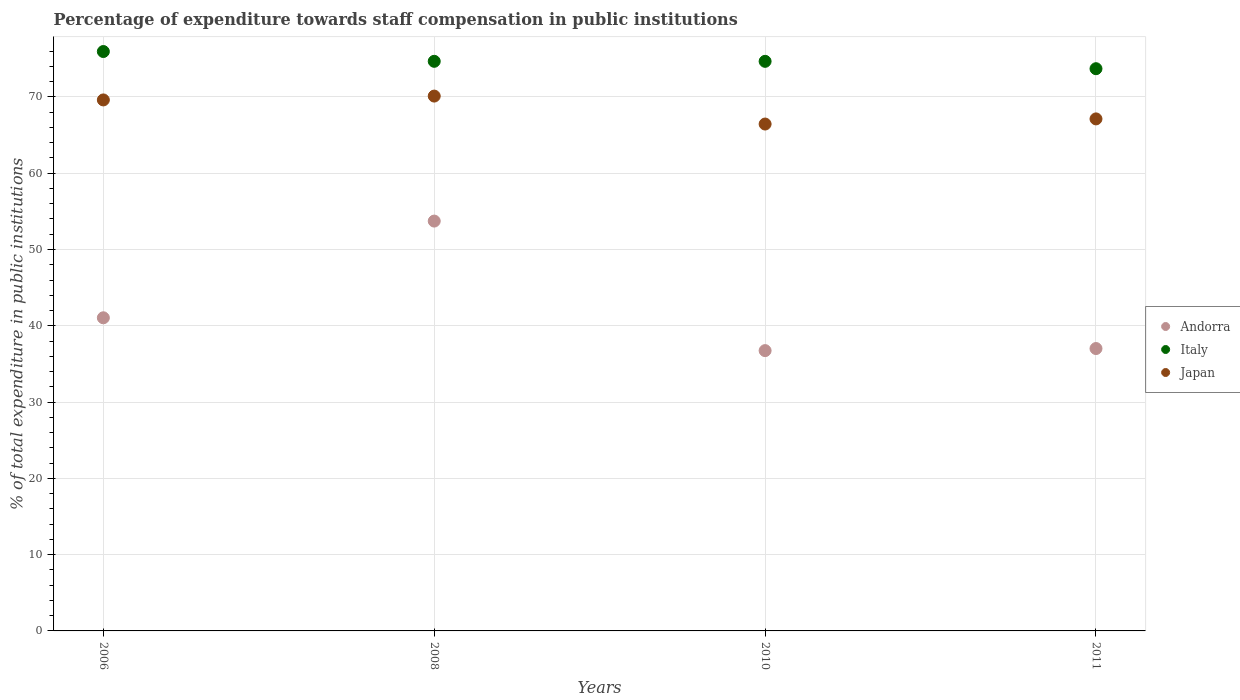What is the percentage of expenditure towards staff compensation in Japan in 2008?
Give a very brief answer. 70.11. Across all years, what is the maximum percentage of expenditure towards staff compensation in Japan?
Provide a succinct answer. 70.11. Across all years, what is the minimum percentage of expenditure towards staff compensation in Italy?
Offer a very short reply. 73.7. In which year was the percentage of expenditure towards staff compensation in Italy maximum?
Keep it short and to the point. 2006. In which year was the percentage of expenditure towards staff compensation in Japan minimum?
Your answer should be compact. 2010. What is the total percentage of expenditure towards staff compensation in Japan in the graph?
Your answer should be very brief. 273.28. What is the difference between the percentage of expenditure towards staff compensation in Italy in 2008 and that in 2011?
Your answer should be very brief. 0.97. What is the difference between the percentage of expenditure towards staff compensation in Italy in 2006 and the percentage of expenditure towards staff compensation in Japan in 2011?
Make the answer very short. 8.83. What is the average percentage of expenditure towards staff compensation in Japan per year?
Offer a terse response. 68.32. In the year 2010, what is the difference between the percentage of expenditure towards staff compensation in Japan and percentage of expenditure towards staff compensation in Italy?
Keep it short and to the point. -8.22. What is the ratio of the percentage of expenditure towards staff compensation in Italy in 2008 to that in 2010?
Your answer should be very brief. 1. Is the percentage of expenditure towards staff compensation in Andorra in 2008 less than that in 2011?
Provide a succinct answer. No. What is the difference between the highest and the second highest percentage of expenditure towards staff compensation in Japan?
Offer a very short reply. 0.51. What is the difference between the highest and the lowest percentage of expenditure towards staff compensation in Japan?
Your answer should be compact. 3.67. In how many years, is the percentage of expenditure towards staff compensation in Japan greater than the average percentage of expenditure towards staff compensation in Japan taken over all years?
Give a very brief answer. 2. Does the percentage of expenditure towards staff compensation in Italy monotonically increase over the years?
Keep it short and to the point. No. Is the percentage of expenditure towards staff compensation in Japan strictly greater than the percentage of expenditure towards staff compensation in Italy over the years?
Provide a succinct answer. No. Is the percentage of expenditure towards staff compensation in Japan strictly less than the percentage of expenditure towards staff compensation in Italy over the years?
Keep it short and to the point. Yes. How many years are there in the graph?
Keep it short and to the point. 4. What is the difference between two consecutive major ticks on the Y-axis?
Offer a terse response. 10. Does the graph contain any zero values?
Make the answer very short. No. Does the graph contain grids?
Your response must be concise. Yes. What is the title of the graph?
Offer a terse response. Percentage of expenditure towards staff compensation in public institutions. Does "Serbia" appear as one of the legend labels in the graph?
Your answer should be compact. No. What is the label or title of the X-axis?
Your answer should be compact. Years. What is the label or title of the Y-axis?
Provide a succinct answer. % of total expenditure in public institutions. What is the % of total expenditure in public institutions of Andorra in 2006?
Offer a terse response. 41.05. What is the % of total expenditure in public institutions of Italy in 2006?
Ensure brevity in your answer.  75.95. What is the % of total expenditure in public institutions of Japan in 2006?
Offer a very short reply. 69.61. What is the % of total expenditure in public institutions of Andorra in 2008?
Provide a short and direct response. 53.72. What is the % of total expenditure in public institutions of Italy in 2008?
Make the answer very short. 74.67. What is the % of total expenditure in public institutions of Japan in 2008?
Offer a terse response. 70.11. What is the % of total expenditure in public institutions of Andorra in 2010?
Your answer should be very brief. 36.74. What is the % of total expenditure in public institutions of Italy in 2010?
Give a very brief answer. 74.66. What is the % of total expenditure in public institutions of Japan in 2010?
Your answer should be very brief. 66.44. What is the % of total expenditure in public institutions in Andorra in 2011?
Provide a succinct answer. 37.02. What is the % of total expenditure in public institutions of Italy in 2011?
Offer a very short reply. 73.7. What is the % of total expenditure in public institutions in Japan in 2011?
Make the answer very short. 67.12. Across all years, what is the maximum % of total expenditure in public institutions in Andorra?
Your answer should be very brief. 53.72. Across all years, what is the maximum % of total expenditure in public institutions in Italy?
Your response must be concise. 75.95. Across all years, what is the maximum % of total expenditure in public institutions of Japan?
Your answer should be compact. 70.11. Across all years, what is the minimum % of total expenditure in public institutions of Andorra?
Keep it short and to the point. 36.74. Across all years, what is the minimum % of total expenditure in public institutions of Italy?
Make the answer very short. 73.7. Across all years, what is the minimum % of total expenditure in public institutions in Japan?
Give a very brief answer. 66.44. What is the total % of total expenditure in public institutions in Andorra in the graph?
Provide a short and direct response. 168.53. What is the total % of total expenditure in public institutions of Italy in the graph?
Ensure brevity in your answer.  298.98. What is the total % of total expenditure in public institutions of Japan in the graph?
Give a very brief answer. 273.28. What is the difference between the % of total expenditure in public institutions of Andorra in 2006 and that in 2008?
Provide a succinct answer. -12.68. What is the difference between the % of total expenditure in public institutions in Italy in 2006 and that in 2008?
Give a very brief answer. 1.28. What is the difference between the % of total expenditure in public institutions of Japan in 2006 and that in 2008?
Provide a succinct answer. -0.51. What is the difference between the % of total expenditure in public institutions in Andorra in 2006 and that in 2010?
Make the answer very short. 4.3. What is the difference between the % of total expenditure in public institutions in Italy in 2006 and that in 2010?
Offer a terse response. 1.29. What is the difference between the % of total expenditure in public institutions of Japan in 2006 and that in 2010?
Give a very brief answer. 3.16. What is the difference between the % of total expenditure in public institutions of Andorra in 2006 and that in 2011?
Offer a very short reply. 4.03. What is the difference between the % of total expenditure in public institutions of Italy in 2006 and that in 2011?
Your response must be concise. 2.25. What is the difference between the % of total expenditure in public institutions of Japan in 2006 and that in 2011?
Your answer should be very brief. 2.49. What is the difference between the % of total expenditure in public institutions in Andorra in 2008 and that in 2010?
Your answer should be very brief. 16.98. What is the difference between the % of total expenditure in public institutions in Italy in 2008 and that in 2010?
Give a very brief answer. 0. What is the difference between the % of total expenditure in public institutions of Japan in 2008 and that in 2010?
Your answer should be compact. 3.67. What is the difference between the % of total expenditure in public institutions in Andorra in 2008 and that in 2011?
Provide a succinct answer. 16.71. What is the difference between the % of total expenditure in public institutions in Italy in 2008 and that in 2011?
Your answer should be very brief. 0.97. What is the difference between the % of total expenditure in public institutions of Japan in 2008 and that in 2011?
Provide a short and direct response. 2.99. What is the difference between the % of total expenditure in public institutions of Andorra in 2010 and that in 2011?
Make the answer very short. -0.27. What is the difference between the % of total expenditure in public institutions of Italy in 2010 and that in 2011?
Provide a succinct answer. 0.97. What is the difference between the % of total expenditure in public institutions of Japan in 2010 and that in 2011?
Your answer should be compact. -0.67. What is the difference between the % of total expenditure in public institutions in Andorra in 2006 and the % of total expenditure in public institutions in Italy in 2008?
Keep it short and to the point. -33.62. What is the difference between the % of total expenditure in public institutions in Andorra in 2006 and the % of total expenditure in public institutions in Japan in 2008?
Your response must be concise. -29.06. What is the difference between the % of total expenditure in public institutions in Italy in 2006 and the % of total expenditure in public institutions in Japan in 2008?
Provide a short and direct response. 5.84. What is the difference between the % of total expenditure in public institutions in Andorra in 2006 and the % of total expenditure in public institutions in Italy in 2010?
Keep it short and to the point. -33.62. What is the difference between the % of total expenditure in public institutions of Andorra in 2006 and the % of total expenditure in public institutions of Japan in 2010?
Your answer should be very brief. -25.4. What is the difference between the % of total expenditure in public institutions in Italy in 2006 and the % of total expenditure in public institutions in Japan in 2010?
Provide a short and direct response. 9.51. What is the difference between the % of total expenditure in public institutions of Andorra in 2006 and the % of total expenditure in public institutions of Italy in 2011?
Ensure brevity in your answer.  -32.65. What is the difference between the % of total expenditure in public institutions in Andorra in 2006 and the % of total expenditure in public institutions in Japan in 2011?
Your answer should be very brief. -26.07. What is the difference between the % of total expenditure in public institutions of Italy in 2006 and the % of total expenditure in public institutions of Japan in 2011?
Offer a very short reply. 8.83. What is the difference between the % of total expenditure in public institutions in Andorra in 2008 and the % of total expenditure in public institutions in Italy in 2010?
Offer a very short reply. -20.94. What is the difference between the % of total expenditure in public institutions in Andorra in 2008 and the % of total expenditure in public institutions in Japan in 2010?
Your response must be concise. -12.72. What is the difference between the % of total expenditure in public institutions of Italy in 2008 and the % of total expenditure in public institutions of Japan in 2010?
Make the answer very short. 8.22. What is the difference between the % of total expenditure in public institutions of Andorra in 2008 and the % of total expenditure in public institutions of Italy in 2011?
Keep it short and to the point. -19.97. What is the difference between the % of total expenditure in public institutions in Andorra in 2008 and the % of total expenditure in public institutions in Japan in 2011?
Offer a terse response. -13.39. What is the difference between the % of total expenditure in public institutions in Italy in 2008 and the % of total expenditure in public institutions in Japan in 2011?
Your answer should be compact. 7.55. What is the difference between the % of total expenditure in public institutions of Andorra in 2010 and the % of total expenditure in public institutions of Italy in 2011?
Your answer should be compact. -36.96. What is the difference between the % of total expenditure in public institutions in Andorra in 2010 and the % of total expenditure in public institutions in Japan in 2011?
Make the answer very short. -30.38. What is the difference between the % of total expenditure in public institutions in Italy in 2010 and the % of total expenditure in public institutions in Japan in 2011?
Offer a very short reply. 7.55. What is the average % of total expenditure in public institutions of Andorra per year?
Offer a terse response. 42.13. What is the average % of total expenditure in public institutions in Italy per year?
Make the answer very short. 74.75. What is the average % of total expenditure in public institutions in Japan per year?
Offer a terse response. 68.32. In the year 2006, what is the difference between the % of total expenditure in public institutions of Andorra and % of total expenditure in public institutions of Italy?
Provide a short and direct response. -34.9. In the year 2006, what is the difference between the % of total expenditure in public institutions of Andorra and % of total expenditure in public institutions of Japan?
Offer a very short reply. -28.56. In the year 2006, what is the difference between the % of total expenditure in public institutions in Italy and % of total expenditure in public institutions in Japan?
Give a very brief answer. 6.34. In the year 2008, what is the difference between the % of total expenditure in public institutions of Andorra and % of total expenditure in public institutions of Italy?
Offer a terse response. -20.94. In the year 2008, what is the difference between the % of total expenditure in public institutions in Andorra and % of total expenditure in public institutions in Japan?
Give a very brief answer. -16.39. In the year 2008, what is the difference between the % of total expenditure in public institutions in Italy and % of total expenditure in public institutions in Japan?
Provide a succinct answer. 4.56. In the year 2010, what is the difference between the % of total expenditure in public institutions in Andorra and % of total expenditure in public institutions in Italy?
Offer a very short reply. -37.92. In the year 2010, what is the difference between the % of total expenditure in public institutions of Andorra and % of total expenditure in public institutions of Japan?
Keep it short and to the point. -29.7. In the year 2010, what is the difference between the % of total expenditure in public institutions of Italy and % of total expenditure in public institutions of Japan?
Offer a very short reply. 8.22. In the year 2011, what is the difference between the % of total expenditure in public institutions in Andorra and % of total expenditure in public institutions in Italy?
Keep it short and to the point. -36.68. In the year 2011, what is the difference between the % of total expenditure in public institutions in Andorra and % of total expenditure in public institutions in Japan?
Provide a succinct answer. -30.1. In the year 2011, what is the difference between the % of total expenditure in public institutions of Italy and % of total expenditure in public institutions of Japan?
Your response must be concise. 6.58. What is the ratio of the % of total expenditure in public institutions in Andorra in 2006 to that in 2008?
Give a very brief answer. 0.76. What is the ratio of the % of total expenditure in public institutions of Italy in 2006 to that in 2008?
Your response must be concise. 1.02. What is the ratio of the % of total expenditure in public institutions in Andorra in 2006 to that in 2010?
Give a very brief answer. 1.12. What is the ratio of the % of total expenditure in public institutions in Italy in 2006 to that in 2010?
Offer a terse response. 1.02. What is the ratio of the % of total expenditure in public institutions in Japan in 2006 to that in 2010?
Provide a succinct answer. 1.05. What is the ratio of the % of total expenditure in public institutions in Andorra in 2006 to that in 2011?
Your answer should be compact. 1.11. What is the ratio of the % of total expenditure in public institutions of Italy in 2006 to that in 2011?
Your answer should be compact. 1.03. What is the ratio of the % of total expenditure in public institutions of Japan in 2006 to that in 2011?
Provide a succinct answer. 1.04. What is the ratio of the % of total expenditure in public institutions of Andorra in 2008 to that in 2010?
Make the answer very short. 1.46. What is the ratio of the % of total expenditure in public institutions in Italy in 2008 to that in 2010?
Ensure brevity in your answer.  1. What is the ratio of the % of total expenditure in public institutions in Japan in 2008 to that in 2010?
Provide a succinct answer. 1.06. What is the ratio of the % of total expenditure in public institutions of Andorra in 2008 to that in 2011?
Your answer should be compact. 1.45. What is the ratio of the % of total expenditure in public institutions in Italy in 2008 to that in 2011?
Give a very brief answer. 1.01. What is the ratio of the % of total expenditure in public institutions in Japan in 2008 to that in 2011?
Keep it short and to the point. 1.04. What is the ratio of the % of total expenditure in public institutions in Italy in 2010 to that in 2011?
Keep it short and to the point. 1.01. What is the difference between the highest and the second highest % of total expenditure in public institutions of Andorra?
Your answer should be very brief. 12.68. What is the difference between the highest and the second highest % of total expenditure in public institutions in Italy?
Provide a short and direct response. 1.28. What is the difference between the highest and the second highest % of total expenditure in public institutions of Japan?
Make the answer very short. 0.51. What is the difference between the highest and the lowest % of total expenditure in public institutions of Andorra?
Make the answer very short. 16.98. What is the difference between the highest and the lowest % of total expenditure in public institutions in Italy?
Give a very brief answer. 2.25. What is the difference between the highest and the lowest % of total expenditure in public institutions of Japan?
Provide a succinct answer. 3.67. 